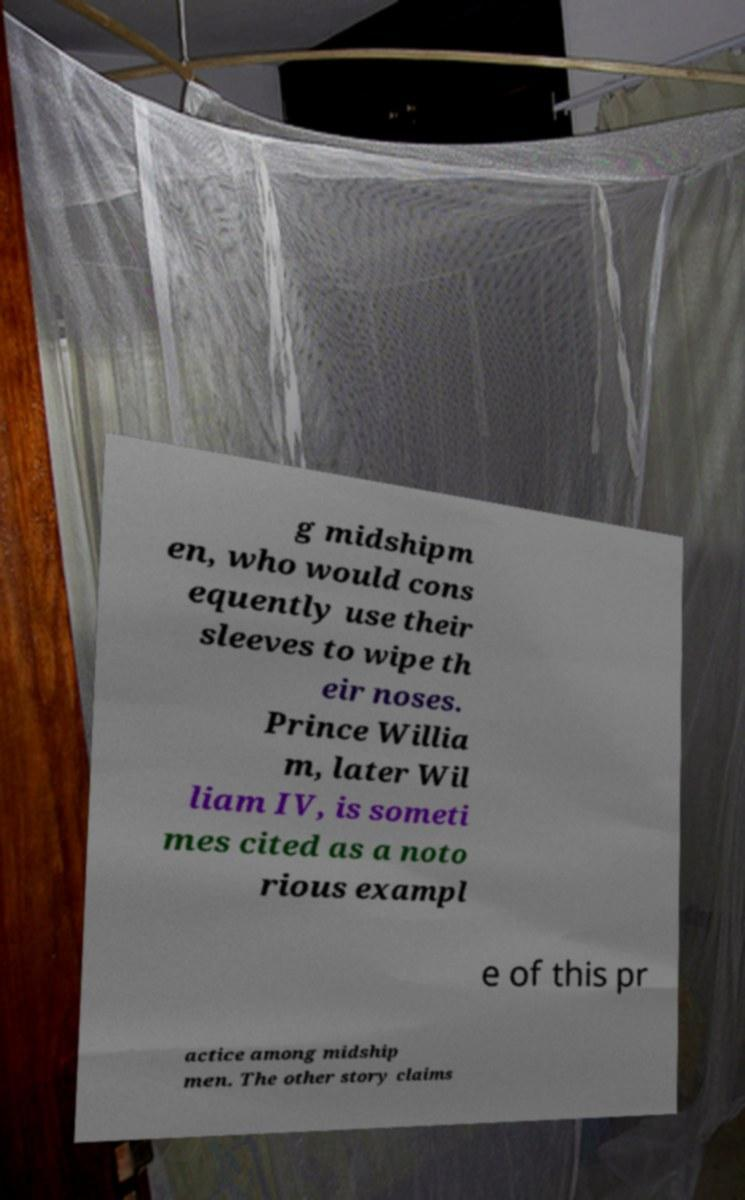What messages or text are displayed in this image? I need them in a readable, typed format. g midshipm en, who would cons equently use their sleeves to wipe th eir noses. Prince Willia m, later Wil liam IV, is someti mes cited as a noto rious exampl e of this pr actice among midship men. The other story claims 